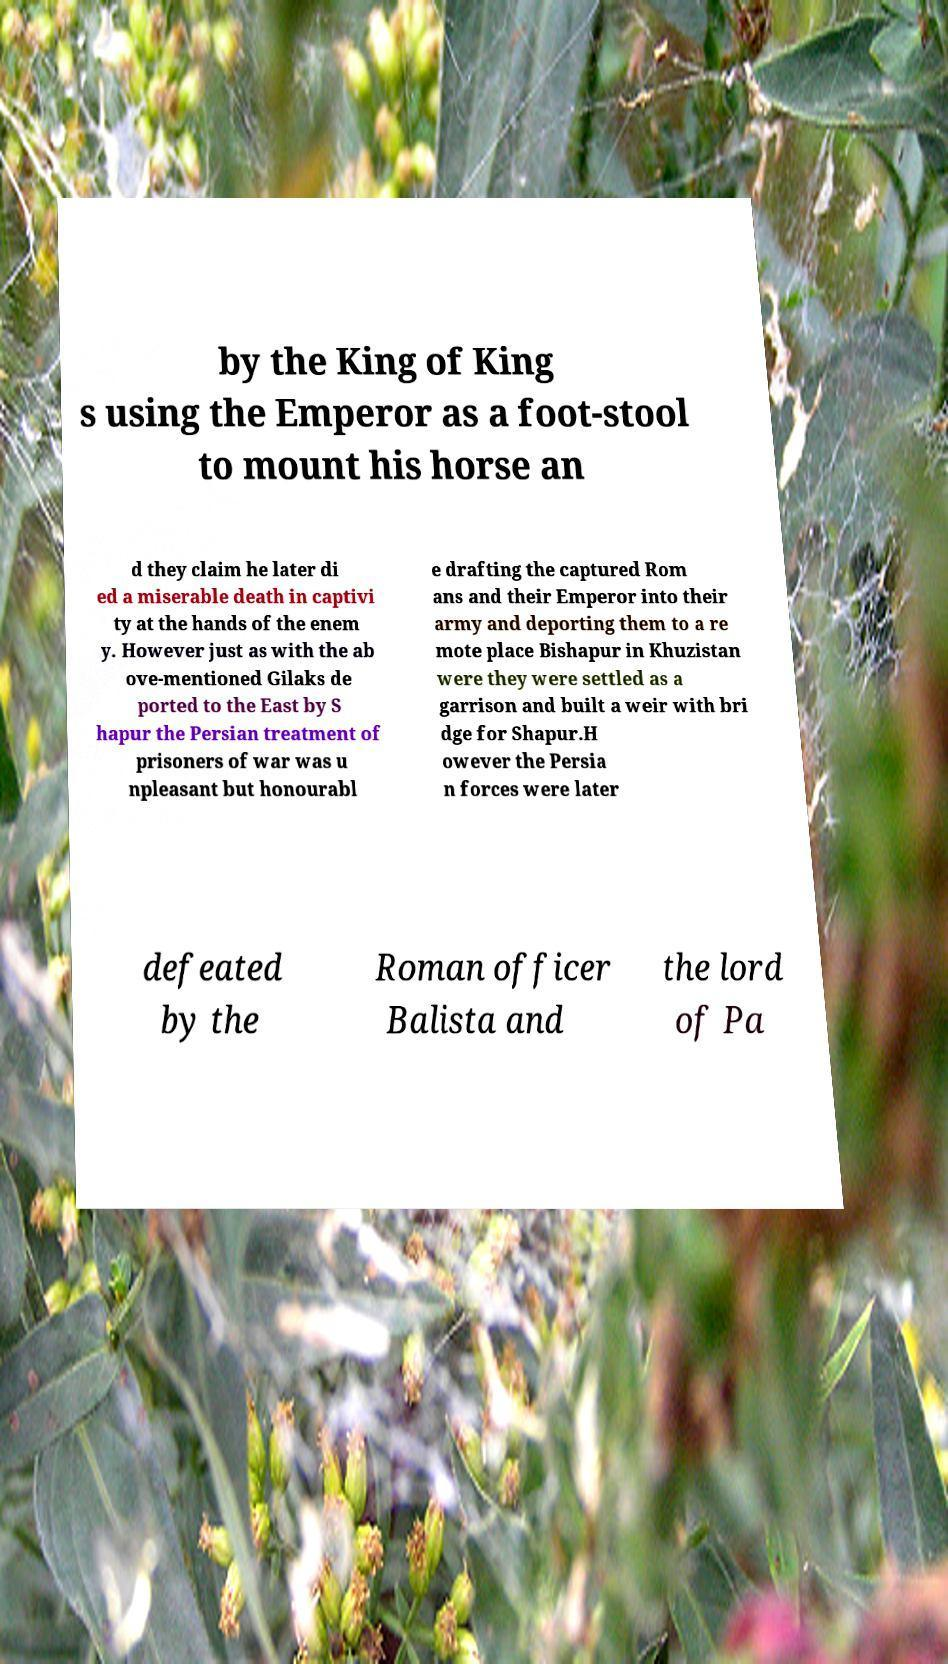I need the written content from this picture converted into text. Can you do that? by the King of King s using the Emperor as a foot-stool to mount his horse an d they claim he later di ed a miserable death in captivi ty at the hands of the enem y. However just as with the ab ove-mentioned Gilaks de ported to the East by S hapur the Persian treatment of prisoners of war was u npleasant but honourabl e drafting the captured Rom ans and their Emperor into their army and deporting them to a re mote place Bishapur in Khuzistan were they were settled as a garrison and built a weir with bri dge for Shapur.H owever the Persia n forces were later defeated by the Roman officer Balista and the lord of Pa 